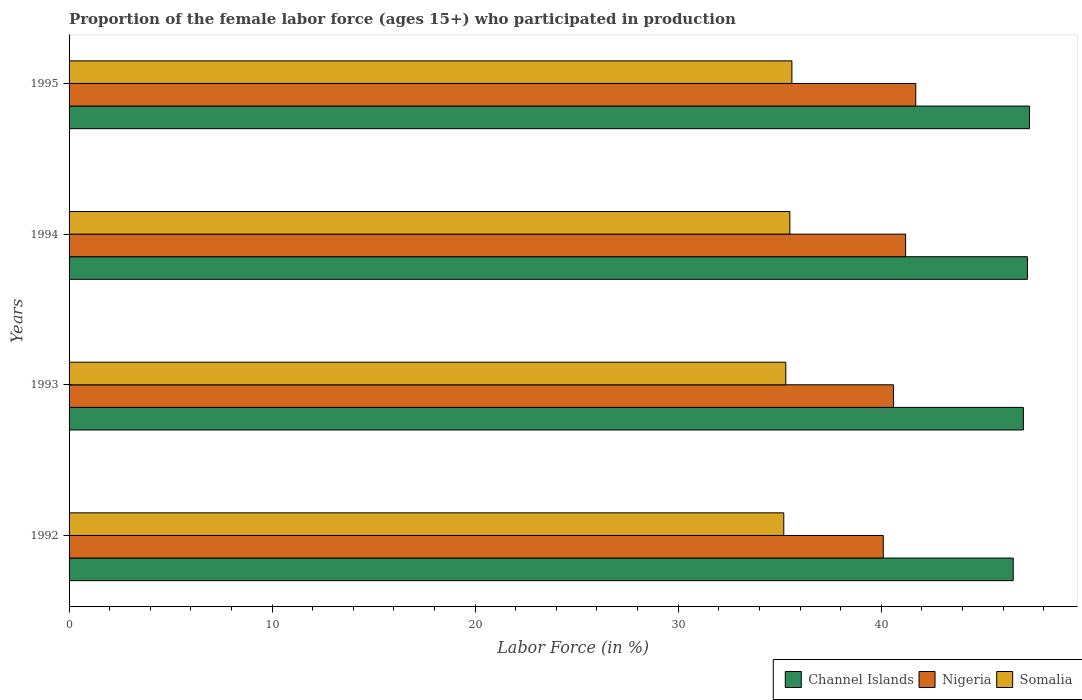How many groups of bars are there?
Your answer should be compact. 4. Are the number of bars per tick equal to the number of legend labels?
Keep it short and to the point. Yes. How many bars are there on the 4th tick from the top?
Provide a short and direct response. 3. How many bars are there on the 1st tick from the bottom?
Offer a very short reply. 3. In how many cases, is the number of bars for a given year not equal to the number of legend labels?
Give a very brief answer. 0. What is the proportion of the female labor force who participated in production in Somalia in 1992?
Ensure brevity in your answer.  35.2. Across all years, what is the maximum proportion of the female labor force who participated in production in Nigeria?
Make the answer very short. 41.7. Across all years, what is the minimum proportion of the female labor force who participated in production in Somalia?
Provide a succinct answer. 35.2. What is the total proportion of the female labor force who participated in production in Channel Islands in the graph?
Offer a terse response. 188. What is the difference between the proportion of the female labor force who participated in production in Channel Islands in 1993 and that in 1995?
Your answer should be compact. -0.3. What is the difference between the proportion of the female labor force who participated in production in Nigeria in 1993 and the proportion of the female labor force who participated in production in Somalia in 1994?
Offer a terse response. 5.1. What is the average proportion of the female labor force who participated in production in Somalia per year?
Make the answer very short. 35.4. In the year 1992, what is the difference between the proportion of the female labor force who participated in production in Somalia and proportion of the female labor force who participated in production in Channel Islands?
Your answer should be very brief. -11.3. In how many years, is the proportion of the female labor force who participated in production in Channel Islands greater than 44 %?
Give a very brief answer. 4. What is the ratio of the proportion of the female labor force who participated in production in Nigeria in 1992 to that in 1994?
Give a very brief answer. 0.97. What is the difference between the highest and the second highest proportion of the female labor force who participated in production in Somalia?
Your response must be concise. 0.1. What is the difference between the highest and the lowest proportion of the female labor force who participated in production in Nigeria?
Offer a terse response. 1.6. In how many years, is the proportion of the female labor force who participated in production in Nigeria greater than the average proportion of the female labor force who participated in production in Nigeria taken over all years?
Provide a short and direct response. 2. What does the 2nd bar from the top in 1995 represents?
Provide a succinct answer. Nigeria. What does the 3rd bar from the bottom in 1992 represents?
Provide a short and direct response. Somalia. Are all the bars in the graph horizontal?
Offer a terse response. Yes. What is the difference between two consecutive major ticks on the X-axis?
Make the answer very short. 10. Are the values on the major ticks of X-axis written in scientific E-notation?
Keep it short and to the point. No. Does the graph contain grids?
Offer a very short reply. No. How are the legend labels stacked?
Make the answer very short. Horizontal. What is the title of the graph?
Offer a terse response. Proportion of the female labor force (ages 15+) who participated in production. What is the label or title of the Y-axis?
Your answer should be very brief. Years. What is the Labor Force (in %) in Channel Islands in 1992?
Your answer should be very brief. 46.5. What is the Labor Force (in %) of Nigeria in 1992?
Provide a succinct answer. 40.1. What is the Labor Force (in %) in Somalia in 1992?
Keep it short and to the point. 35.2. What is the Labor Force (in %) in Nigeria in 1993?
Offer a very short reply. 40.6. What is the Labor Force (in %) in Somalia in 1993?
Your response must be concise. 35.3. What is the Labor Force (in %) of Channel Islands in 1994?
Make the answer very short. 47.2. What is the Labor Force (in %) of Nigeria in 1994?
Ensure brevity in your answer.  41.2. What is the Labor Force (in %) in Somalia in 1994?
Provide a succinct answer. 35.5. What is the Labor Force (in %) of Channel Islands in 1995?
Give a very brief answer. 47.3. What is the Labor Force (in %) of Nigeria in 1995?
Give a very brief answer. 41.7. What is the Labor Force (in %) of Somalia in 1995?
Make the answer very short. 35.6. Across all years, what is the maximum Labor Force (in %) in Channel Islands?
Your response must be concise. 47.3. Across all years, what is the maximum Labor Force (in %) in Nigeria?
Your response must be concise. 41.7. Across all years, what is the maximum Labor Force (in %) in Somalia?
Your answer should be compact. 35.6. Across all years, what is the minimum Labor Force (in %) in Channel Islands?
Your answer should be compact. 46.5. Across all years, what is the minimum Labor Force (in %) in Nigeria?
Your answer should be very brief. 40.1. Across all years, what is the minimum Labor Force (in %) of Somalia?
Your answer should be compact. 35.2. What is the total Labor Force (in %) in Channel Islands in the graph?
Offer a very short reply. 188. What is the total Labor Force (in %) in Nigeria in the graph?
Your answer should be compact. 163.6. What is the total Labor Force (in %) in Somalia in the graph?
Your answer should be very brief. 141.6. What is the difference between the Labor Force (in %) in Somalia in 1992 and that in 1993?
Provide a short and direct response. -0.1. What is the difference between the Labor Force (in %) in Channel Islands in 1992 and that in 1994?
Give a very brief answer. -0.7. What is the difference between the Labor Force (in %) of Nigeria in 1992 and that in 1994?
Provide a succinct answer. -1.1. What is the difference between the Labor Force (in %) in Nigeria in 1992 and that in 1995?
Your answer should be very brief. -1.6. What is the difference between the Labor Force (in %) in Somalia in 1992 and that in 1995?
Give a very brief answer. -0.4. What is the difference between the Labor Force (in %) in Channel Islands in 1993 and that in 1994?
Your response must be concise. -0.2. What is the difference between the Labor Force (in %) in Nigeria in 1993 and that in 1994?
Offer a terse response. -0.6. What is the difference between the Labor Force (in %) in Somalia in 1993 and that in 1995?
Your answer should be compact. -0.3. What is the difference between the Labor Force (in %) of Somalia in 1994 and that in 1995?
Your response must be concise. -0.1. What is the difference between the Labor Force (in %) of Channel Islands in 1992 and the Labor Force (in %) of Somalia in 1994?
Give a very brief answer. 11. What is the difference between the Labor Force (in %) of Channel Islands in 1992 and the Labor Force (in %) of Nigeria in 1995?
Your answer should be very brief. 4.8. What is the difference between the Labor Force (in %) of Channel Islands in 1993 and the Labor Force (in %) of Somalia in 1994?
Offer a very short reply. 11.5. What is the difference between the Labor Force (in %) of Nigeria in 1993 and the Labor Force (in %) of Somalia in 1994?
Your answer should be very brief. 5.1. What is the difference between the Labor Force (in %) of Channel Islands in 1993 and the Labor Force (in %) of Somalia in 1995?
Provide a short and direct response. 11.4. What is the difference between the Labor Force (in %) in Channel Islands in 1994 and the Labor Force (in %) in Somalia in 1995?
Your answer should be compact. 11.6. What is the difference between the Labor Force (in %) in Nigeria in 1994 and the Labor Force (in %) in Somalia in 1995?
Provide a succinct answer. 5.6. What is the average Labor Force (in %) in Channel Islands per year?
Ensure brevity in your answer.  47. What is the average Labor Force (in %) in Nigeria per year?
Offer a very short reply. 40.9. What is the average Labor Force (in %) of Somalia per year?
Provide a succinct answer. 35.4. In the year 1992, what is the difference between the Labor Force (in %) of Channel Islands and Labor Force (in %) of Nigeria?
Make the answer very short. 6.4. In the year 1992, what is the difference between the Labor Force (in %) of Nigeria and Labor Force (in %) of Somalia?
Your answer should be compact. 4.9. In the year 1993, what is the difference between the Labor Force (in %) of Channel Islands and Labor Force (in %) of Somalia?
Provide a short and direct response. 11.7. In the year 1994, what is the difference between the Labor Force (in %) of Channel Islands and Labor Force (in %) of Somalia?
Offer a terse response. 11.7. In the year 1994, what is the difference between the Labor Force (in %) in Nigeria and Labor Force (in %) in Somalia?
Your response must be concise. 5.7. In the year 1995, what is the difference between the Labor Force (in %) of Channel Islands and Labor Force (in %) of Nigeria?
Offer a terse response. 5.6. In the year 1995, what is the difference between the Labor Force (in %) of Channel Islands and Labor Force (in %) of Somalia?
Your answer should be compact. 11.7. In the year 1995, what is the difference between the Labor Force (in %) of Nigeria and Labor Force (in %) of Somalia?
Provide a succinct answer. 6.1. What is the ratio of the Labor Force (in %) in Channel Islands in 1992 to that in 1993?
Make the answer very short. 0.99. What is the ratio of the Labor Force (in %) in Channel Islands in 1992 to that in 1994?
Your answer should be compact. 0.99. What is the ratio of the Labor Force (in %) of Nigeria in 1992 to that in 1994?
Provide a succinct answer. 0.97. What is the ratio of the Labor Force (in %) in Channel Islands in 1992 to that in 1995?
Your response must be concise. 0.98. What is the ratio of the Labor Force (in %) in Nigeria in 1992 to that in 1995?
Offer a very short reply. 0.96. What is the ratio of the Labor Force (in %) in Channel Islands in 1993 to that in 1994?
Offer a very short reply. 1. What is the ratio of the Labor Force (in %) in Nigeria in 1993 to that in 1994?
Give a very brief answer. 0.99. What is the ratio of the Labor Force (in %) of Somalia in 1993 to that in 1994?
Provide a succinct answer. 0.99. What is the ratio of the Labor Force (in %) of Channel Islands in 1993 to that in 1995?
Keep it short and to the point. 0.99. What is the ratio of the Labor Force (in %) of Nigeria in 1993 to that in 1995?
Make the answer very short. 0.97. What is the ratio of the Labor Force (in %) in Somalia in 1993 to that in 1995?
Keep it short and to the point. 0.99. What is the ratio of the Labor Force (in %) of Channel Islands in 1994 to that in 1995?
Give a very brief answer. 1. What is the ratio of the Labor Force (in %) in Nigeria in 1994 to that in 1995?
Give a very brief answer. 0.99. What is the difference between the highest and the second highest Labor Force (in %) of Somalia?
Provide a succinct answer. 0.1. What is the difference between the highest and the lowest Labor Force (in %) of Channel Islands?
Offer a terse response. 0.8. 